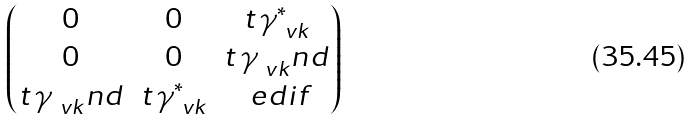Convert formula to latex. <formula><loc_0><loc_0><loc_500><loc_500>\begin{pmatrix} 0 & 0 & t \, \gamma _ { \ v k } ^ { * } \\ 0 & 0 & t \, \gamma _ { \ v k } ^ { \ } n d \\ t \, \gamma _ { \ v k } ^ { \ } n d & t \, \gamma _ { \ v k } ^ { * } & \ e d i f \end{pmatrix}</formula> 